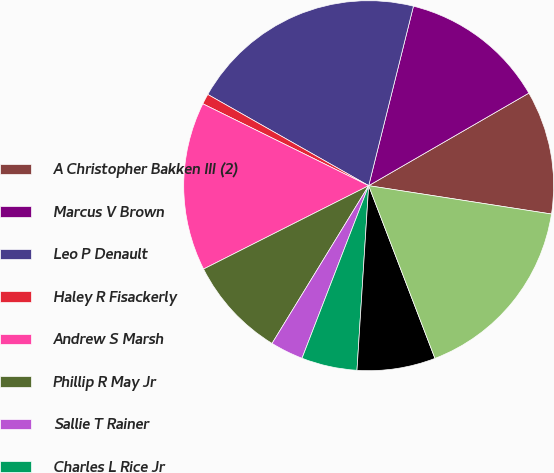<chart> <loc_0><loc_0><loc_500><loc_500><pie_chart><fcel>A Christopher Bakken III (2)<fcel>Marcus V Brown<fcel>Leo P Denault<fcel>Haley R Fisackerly<fcel>Andrew S Marsh<fcel>Phillip R May Jr<fcel>Sallie T Rainer<fcel>Charles L Rice Jr<fcel>Richard C Riley<fcel>Roderick K West<nl><fcel>10.79%<fcel>12.77%<fcel>20.68%<fcel>0.91%<fcel>14.74%<fcel>8.81%<fcel>2.88%<fcel>4.86%<fcel>6.84%<fcel>16.72%<nl></chart> 